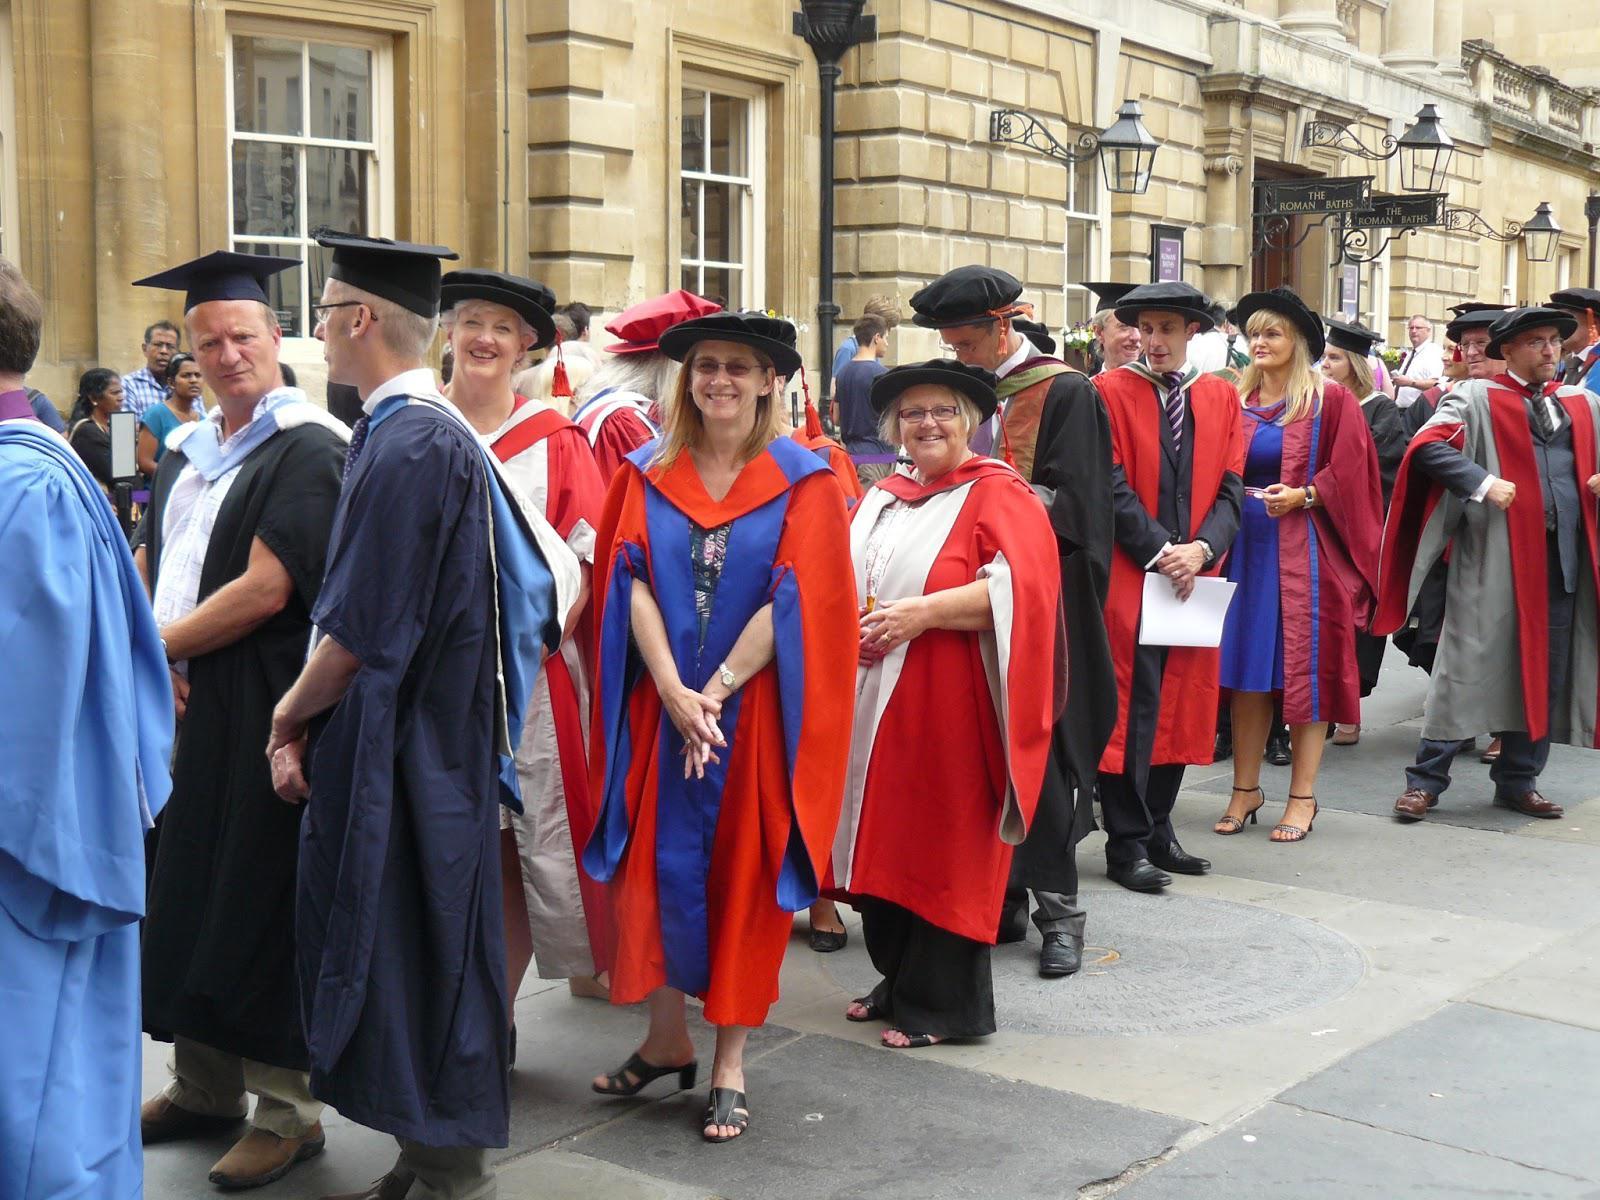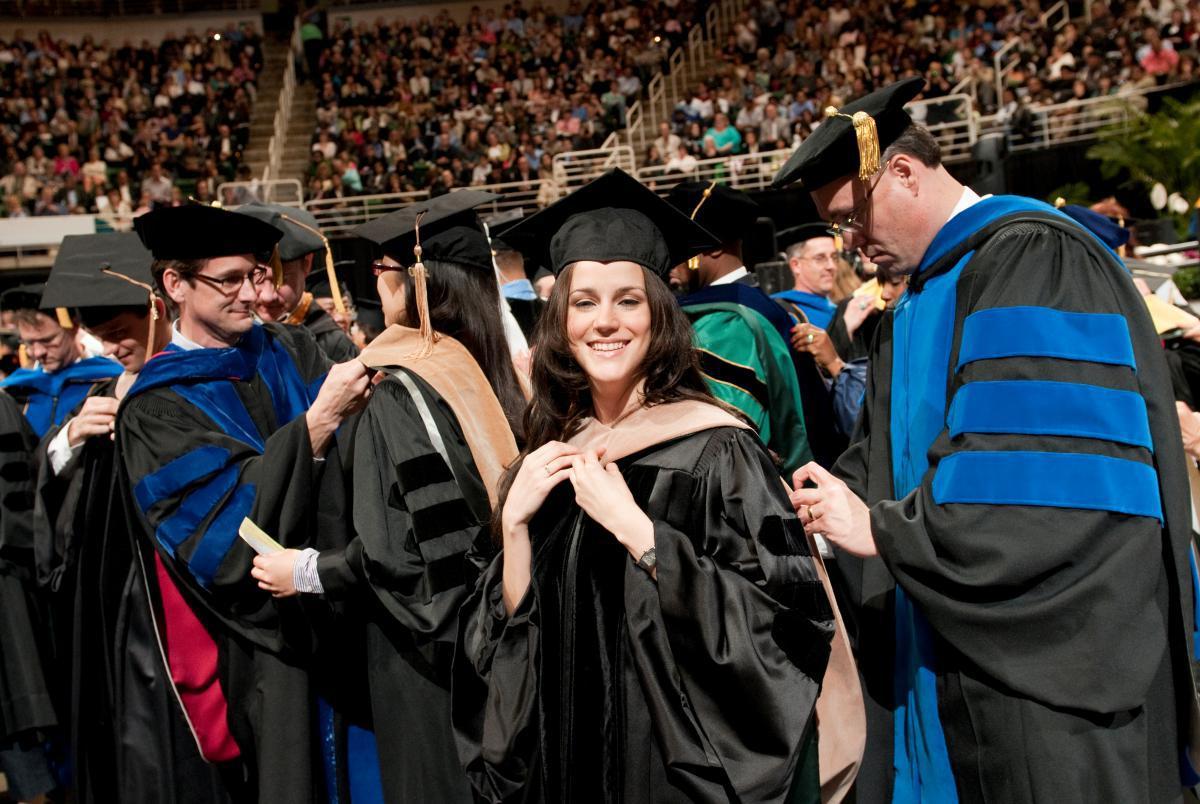The first image is the image on the left, the second image is the image on the right. Evaluate the accuracy of this statement regarding the images: "Right image shows at least one person in a dark red graduation gown with black stripes on the sleeves.". Is it true? Answer yes or no. No. The first image is the image on the left, the second image is the image on the right. Given the left and right images, does the statement "Graduates are standing on the sidewalk in the image on the left." hold true? Answer yes or no. Yes. 